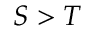Convert formula to latex. <formula><loc_0><loc_0><loc_500><loc_500>S > T</formula> 